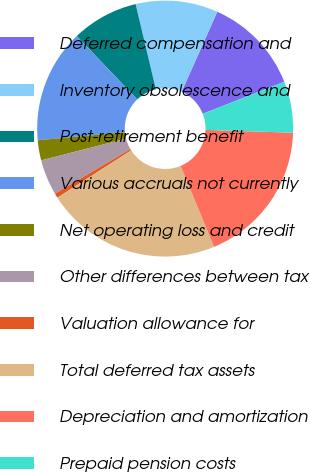Convert chart. <chart><loc_0><loc_0><loc_500><loc_500><pie_chart><fcel>Deferred compensation and<fcel>Inventory obsolescence and<fcel>Post-retirement benefit<fcel>Various accruals not currently<fcel>Net operating loss and credit<fcel>Other differences between tax<fcel>Valuation allowance for<fcel>Total deferred tax assets<fcel>Depreciation and amortization<fcel>Prepaid pension costs<nl><fcel>12.36%<fcel>10.39%<fcel>8.43%<fcel>14.32%<fcel>2.54%<fcel>4.5%<fcel>0.58%<fcel>22.17%<fcel>18.25%<fcel>6.47%<nl></chart> 